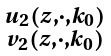<formula> <loc_0><loc_0><loc_500><loc_500>\begin{smallmatrix} u _ { 2 } ( z , \cdot , k _ { 0 } ) \\ v _ { 2 } ( z , \cdot , k _ { 0 } ) \end{smallmatrix}</formula> 